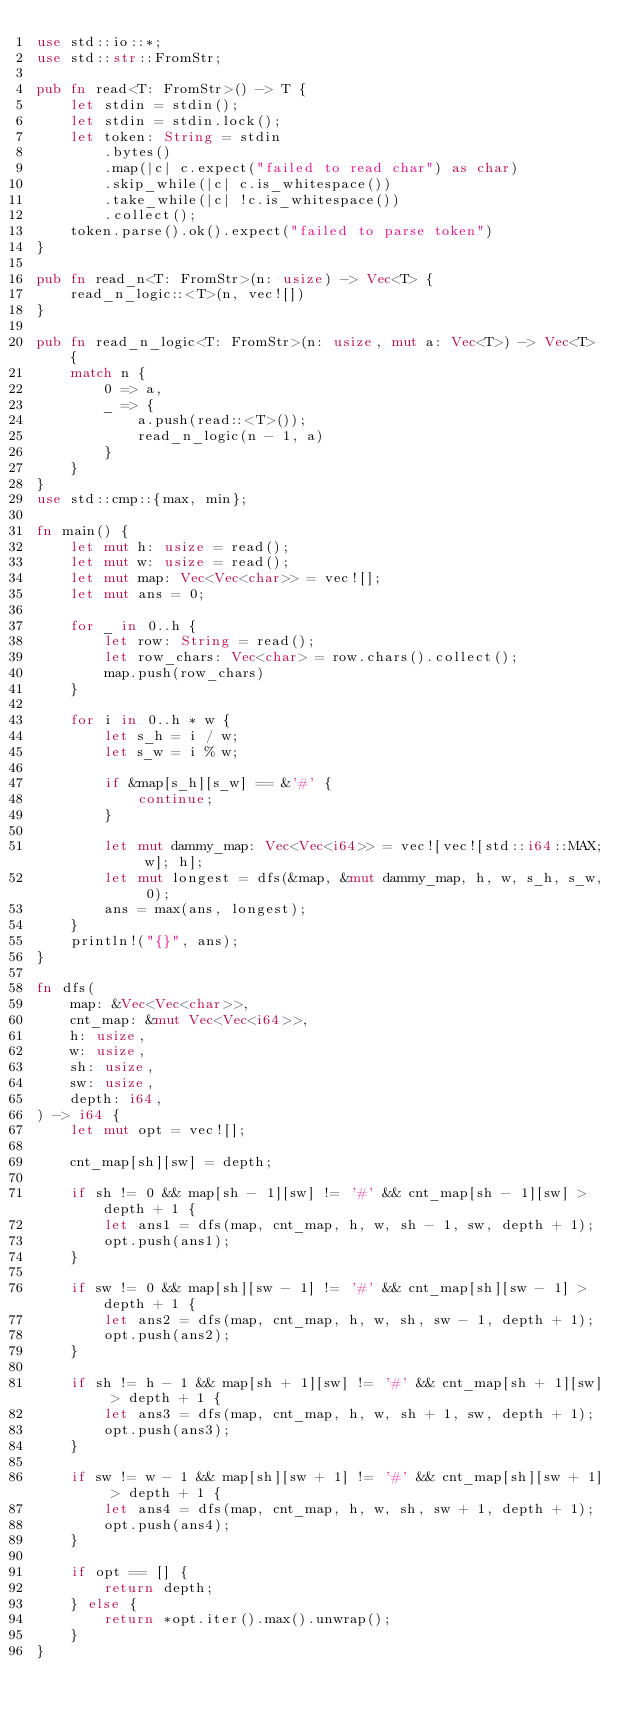Convert code to text. <code><loc_0><loc_0><loc_500><loc_500><_Rust_>use std::io::*;
use std::str::FromStr;

pub fn read<T: FromStr>() -> T {
    let stdin = stdin();
    let stdin = stdin.lock();
    let token: String = stdin
        .bytes()
        .map(|c| c.expect("failed to read char") as char)
        .skip_while(|c| c.is_whitespace())
        .take_while(|c| !c.is_whitespace())
        .collect();
    token.parse().ok().expect("failed to parse token")
}

pub fn read_n<T: FromStr>(n: usize) -> Vec<T> {
    read_n_logic::<T>(n, vec![])
}

pub fn read_n_logic<T: FromStr>(n: usize, mut a: Vec<T>) -> Vec<T> {
    match n {
        0 => a,
        _ => {
            a.push(read::<T>());
            read_n_logic(n - 1, a)
        }
    }
}
use std::cmp::{max, min};

fn main() {
    let mut h: usize = read();
    let mut w: usize = read();
    let mut map: Vec<Vec<char>> = vec![];
    let mut ans = 0;

    for _ in 0..h {
        let row: String = read();
        let row_chars: Vec<char> = row.chars().collect();
        map.push(row_chars)
    }

    for i in 0..h * w {
        let s_h = i / w;
        let s_w = i % w;

        if &map[s_h][s_w] == &'#' {
            continue;
        }

        let mut dammy_map: Vec<Vec<i64>> = vec![vec![std::i64::MAX; w]; h];
        let mut longest = dfs(&map, &mut dammy_map, h, w, s_h, s_w, 0);
        ans = max(ans, longest);
    }
    println!("{}", ans);
}

fn dfs(
    map: &Vec<Vec<char>>,
    cnt_map: &mut Vec<Vec<i64>>,
    h: usize,
    w: usize,
    sh: usize,
    sw: usize,
    depth: i64,
) -> i64 {
    let mut opt = vec![];

    cnt_map[sh][sw] = depth;

    if sh != 0 && map[sh - 1][sw] != '#' && cnt_map[sh - 1][sw] > depth + 1 {
        let ans1 = dfs(map, cnt_map, h, w, sh - 1, sw, depth + 1);
        opt.push(ans1);
    }

    if sw != 0 && map[sh][sw - 1] != '#' && cnt_map[sh][sw - 1] > depth + 1 {
        let ans2 = dfs(map, cnt_map, h, w, sh, sw - 1, depth + 1);
        opt.push(ans2);
    }

    if sh != h - 1 && map[sh + 1][sw] != '#' && cnt_map[sh + 1][sw] > depth + 1 {
        let ans3 = dfs(map, cnt_map, h, w, sh + 1, sw, depth + 1);
        opt.push(ans3);
    }

    if sw != w - 1 && map[sh][sw + 1] != '#' && cnt_map[sh][sw + 1] > depth + 1 {
        let ans4 = dfs(map, cnt_map, h, w, sh, sw + 1, depth + 1);
        opt.push(ans4);
    }

    if opt == [] {
        return depth;
    } else {
        return *opt.iter().max().unwrap();
    }
}
</code> 